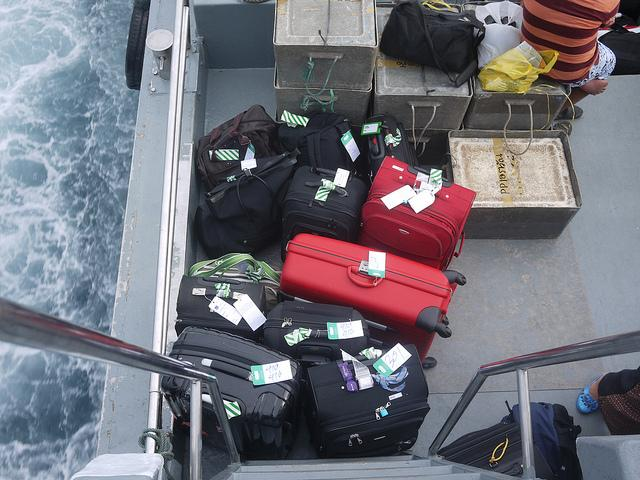How are bags identified here? tags 